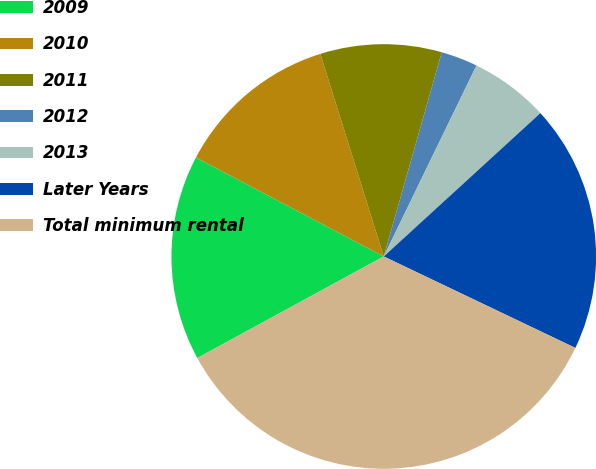<chart> <loc_0><loc_0><loc_500><loc_500><pie_chart><fcel>2009<fcel>2010<fcel>2011<fcel>2012<fcel>2013<fcel>Later Years<fcel>Total minimum rental<nl><fcel>15.66%<fcel>12.45%<fcel>9.23%<fcel>2.79%<fcel>6.01%<fcel>18.88%<fcel>34.97%<nl></chart> 